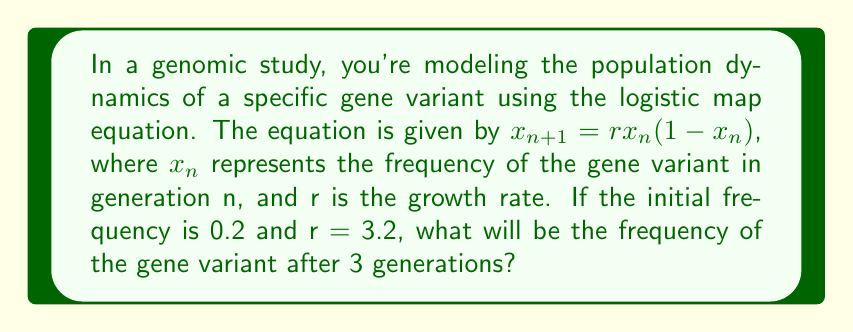Can you solve this math problem? To solve this problem, we need to iterate the logistic map equation for 3 generations:

1. Initial condition: $x_0 = 0.2$, $r = 3.2$

2. First generation ($n = 1$):
   $x_1 = rx_0(1-x_0)$
   $x_1 = 3.2 \cdot 0.2 \cdot (1-0.2)$
   $x_1 = 3.2 \cdot 0.2 \cdot 0.8 = 0.512$

3. Second generation ($n = 2$):
   $x_2 = rx_1(1-x_1)$
   $x_2 = 3.2 \cdot 0.512 \cdot (1-0.512)$
   $x_2 = 3.2 \cdot 0.512 \cdot 0.488 = 0.799744$

4. Third generation ($n = 3$):
   $x_3 = rx_2(1-x_2)$
   $x_3 = 3.2 \cdot 0.799744 \cdot (1-0.799744)$
   $x_3 = 3.2 \cdot 0.799744 \cdot 0.200256 \approx 0.513024$

Therefore, after 3 generations, the frequency of the gene variant will be approximately 0.513024.
Answer: 0.513024 